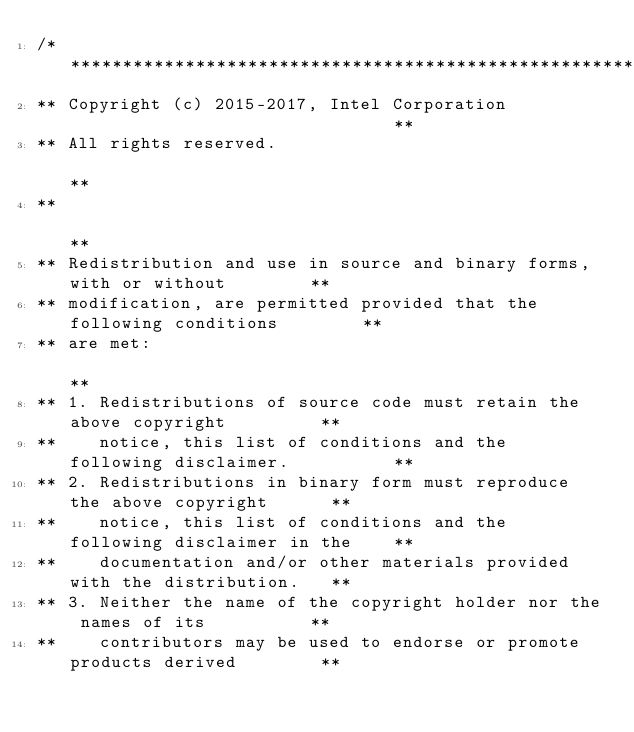Convert code to text. <code><loc_0><loc_0><loc_500><loc_500><_C++_>/******************************************************************************
** Copyright (c) 2015-2017, Intel Corporation                                **
** All rights reserved.                                                      **
**                                                                           **
** Redistribution and use in source and binary forms, with or without        **
** modification, are permitted provided that the following conditions        **
** are met:                                                                  **
** 1. Redistributions of source code must retain the above copyright         **
**    notice, this list of conditions and the following disclaimer.          **
** 2. Redistributions in binary form must reproduce the above copyright      **
**    notice, this list of conditions and the following disclaimer in the    **
**    documentation and/or other materials provided with the distribution.   **
** 3. Neither the name of the copyright holder nor the names of its          **
**    contributors may be used to endorse or promote products derived        **</code> 